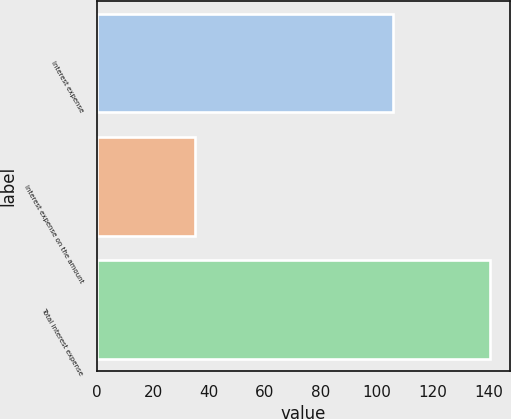Convert chart. <chart><loc_0><loc_0><loc_500><loc_500><bar_chart><fcel>Interest expense<fcel>Interest expense on the amount<fcel>Total interest expense<nl><fcel>105.6<fcel>35<fcel>140.6<nl></chart> 